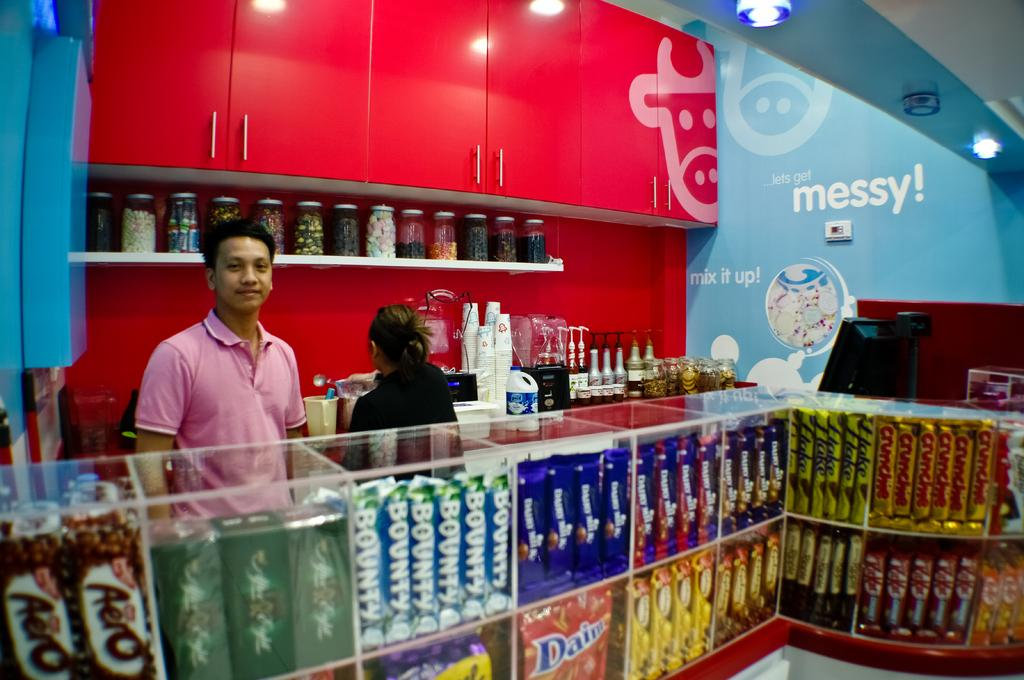<image>
Offer a succinct explanation of the picture presented. On the walls of this store are messages that say messy and mix it up. 